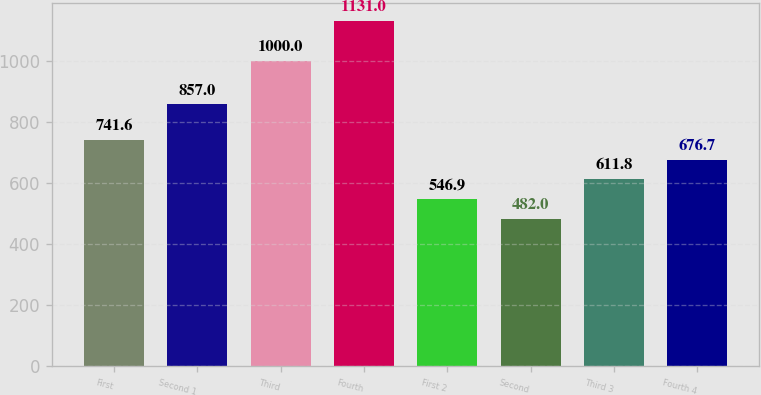Convert chart. <chart><loc_0><loc_0><loc_500><loc_500><bar_chart><fcel>First<fcel>Second 1<fcel>Third<fcel>Fourth<fcel>First 2<fcel>Second<fcel>Third 3<fcel>Fourth 4<nl><fcel>741.6<fcel>857<fcel>1000<fcel>1131<fcel>546.9<fcel>482<fcel>611.8<fcel>676.7<nl></chart> 